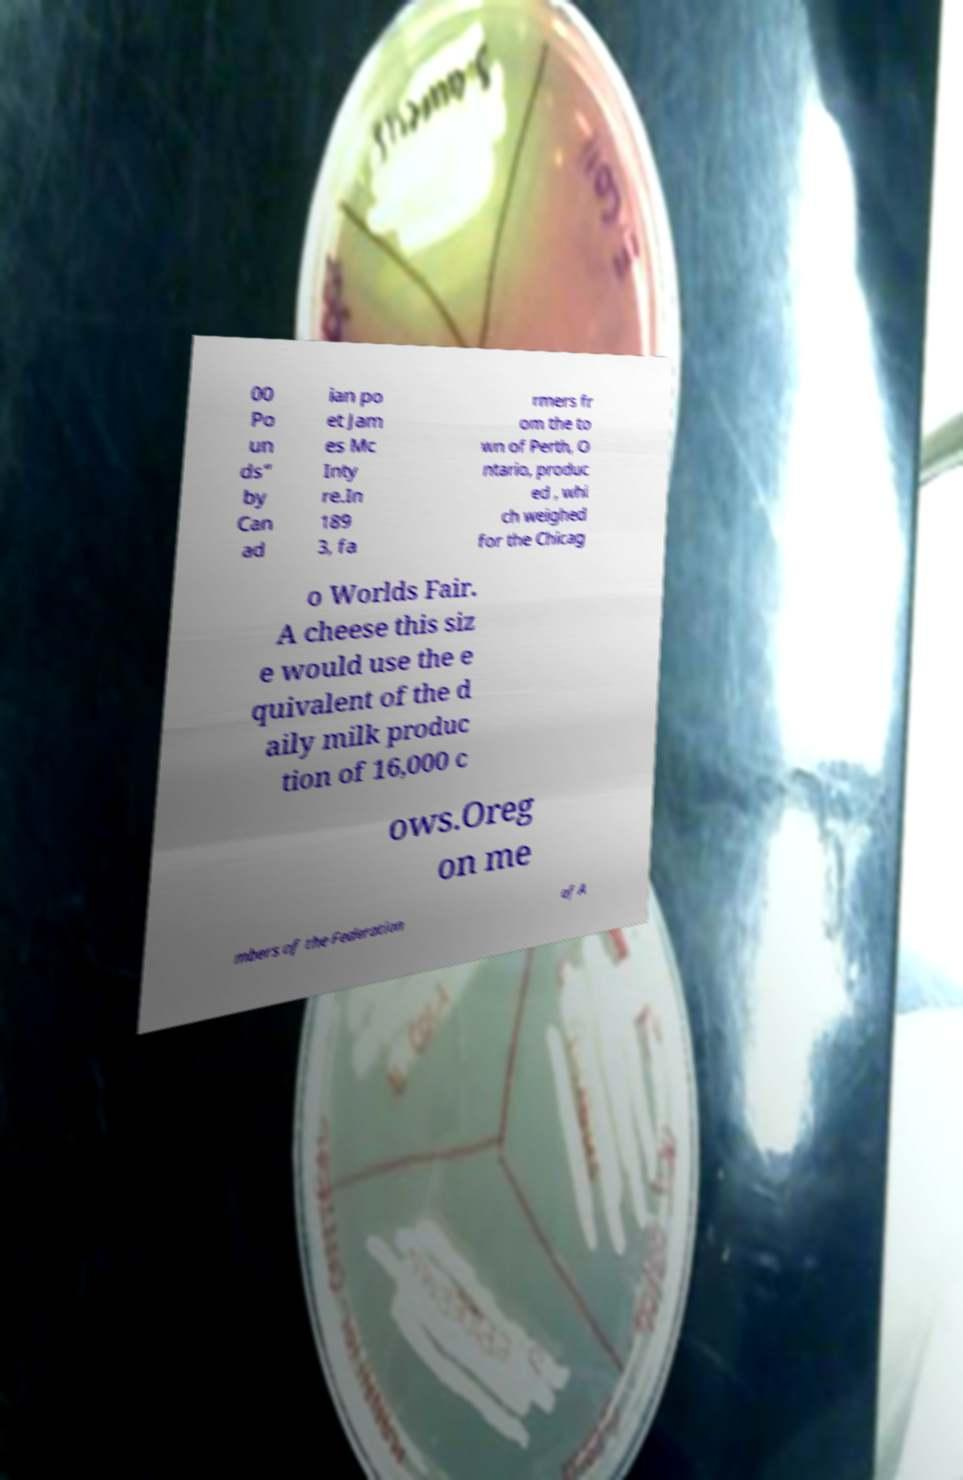Could you assist in decoding the text presented in this image and type it out clearly? 00 Po un ds" by Can ad ian po et Jam es Mc Inty re.In 189 3, fa rmers fr om the to wn of Perth, O ntario, produc ed , whi ch weighed for the Chicag o Worlds Fair. A cheese this siz e would use the e quivalent of the d aily milk produc tion of 16,000 c ows.Oreg on me mbers of the Federation of A 